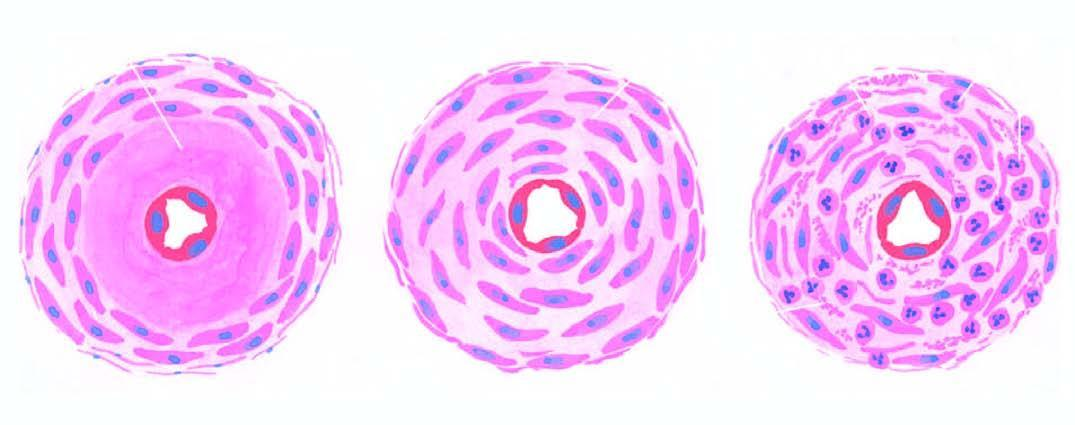how many forms of arteriolosclerosis is seen in hypertension?
Answer the question using a single word or phrase. Three 